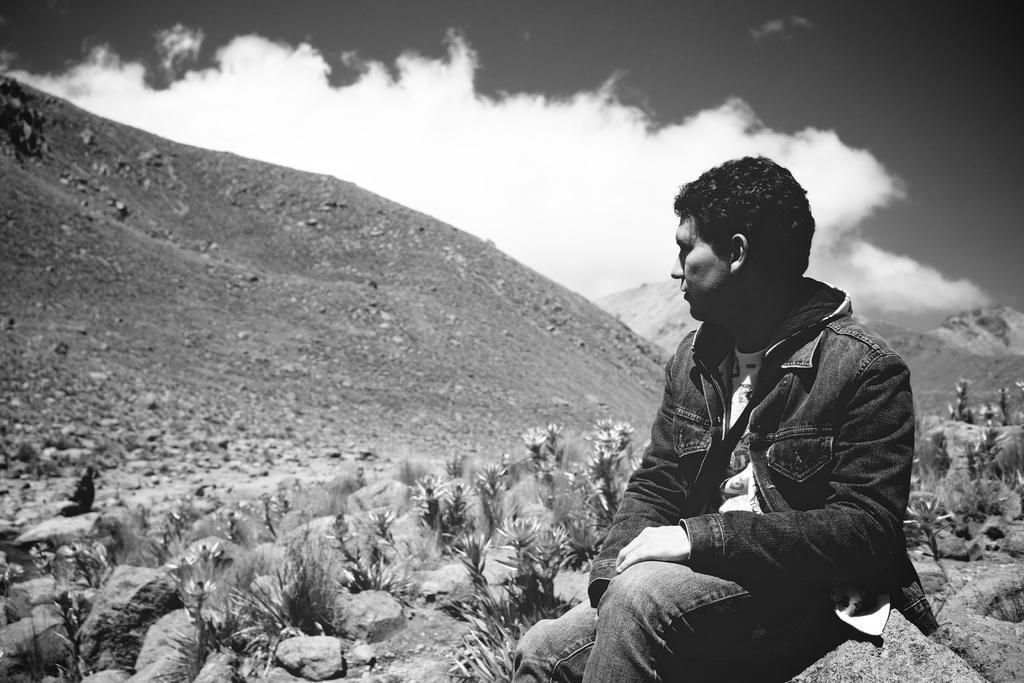What is the color scheme of the image? The image is black and white. What is the man in the image doing? The man is sitting on a rock in the image. What type of natural elements can be seen in the image? There are plants and stones visible in the image. What type of landscape is depicted in the image? The hills are visible in the image. What is the weather like in the image? The sky is cloudy in the image. How many clams can be seen in the image? There are no clams present in the image. What type of loss is the man experiencing in the image? There is no indication of any loss in the image; the man is simply sitting on a rock. 